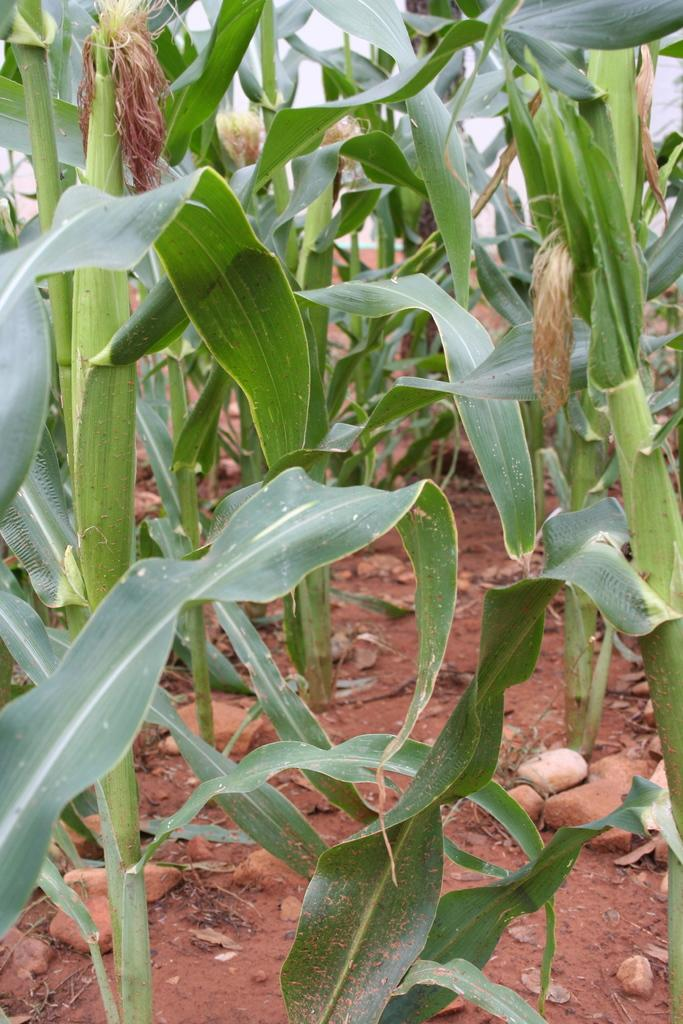What is located in the center of the image? There is soil, stones, and plants in the center of the image. Can you describe the soil in the image? The soil is in the center of the image. What else is present in the center of the image besides soil? There are stones and plants in the center of the image. What type of plants can be seen in the image? The image shows plants in the center. How many beds are visible in the image? There are no beds present in the image. What type of pickle is being used to water the plants in the image? There is: There is no pickle present in the image, and the plants are not being watered with a pickle. 